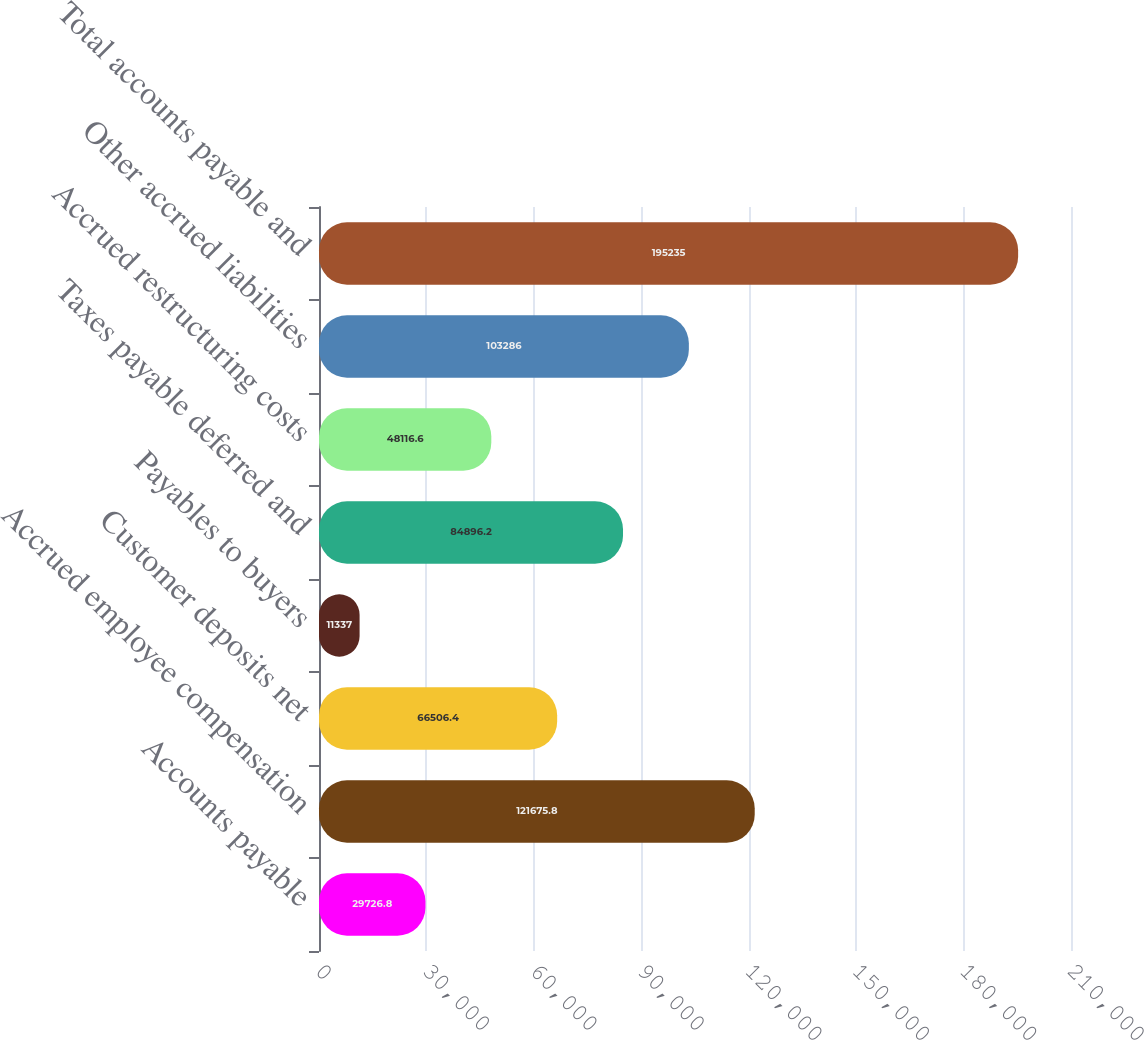<chart> <loc_0><loc_0><loc_500><loc_500><bar_chart><fcel>Accounts payable<fcel>Accrued employee compensation<fcel>Customer deposits net<fcel>Payables to buyers<fcel>Taxes payable deferred and<fcel>Accrued restructuring costs<fcel>Other accrued liabilities<fcel>Total accounts payable and<nl><fcel>29726.8<fcel>121676<fcel>66506.4<fcel>11337<fcel>84896.2<fcel>48116.6<fcel>103286<fcel>195235<nl></chart> 